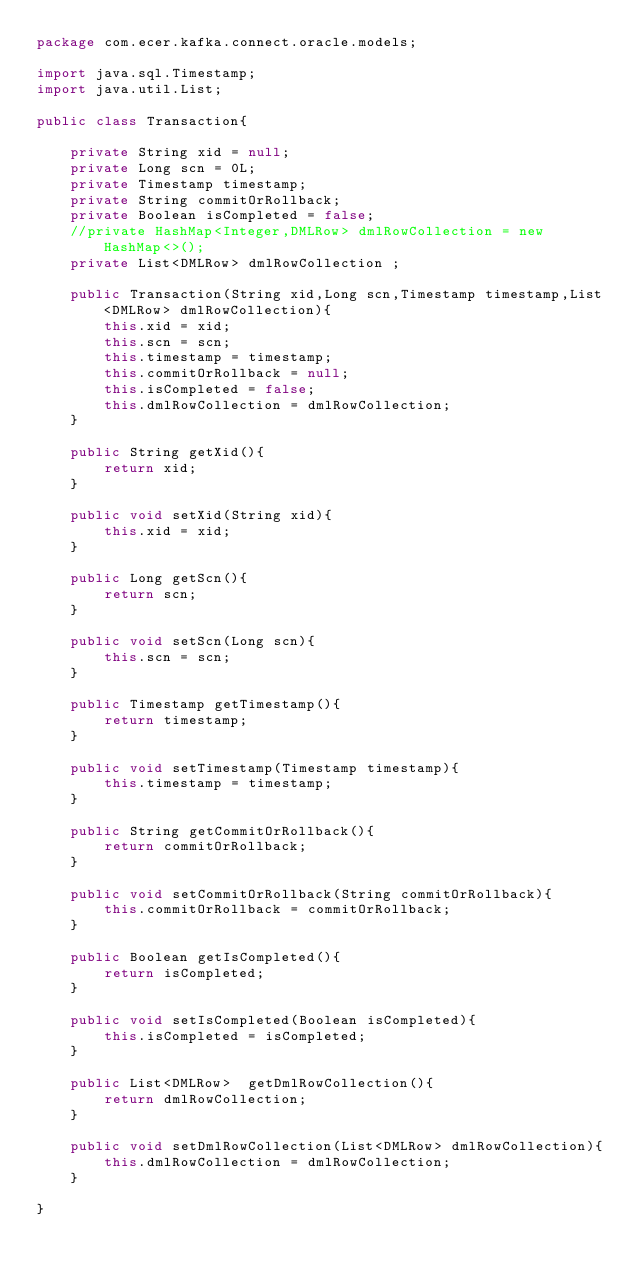Convert code to text. <code><loc_0><loc_0><loc_500><loc_500><_Java_>package com.ecer.kafka.connect.oracle.models;

import java.sql.Timestamp;
import java.util.List;

public class Transaction{

    private String xid = null;
    private Long scn = 0L;
    private Timestamp timestamp;
    private String commitOrRollback;
    private Boolean isCompleted = false;    
    //private HashMap<Integer,DMLRow> dmlRowCollection = new HashMap<>();    
    private List<DMLRow> dmlRowCollection ;

    public Transaction(String xid,Long scn,Timestamp timestamp,List<DMLRow> dmlRowCollection){
        this.xid = xid;
        this.scn = scn;
        this.timestamp = timestamp;
        this.commitOrRollback = null;
        this.isCompleted = false;
        this.dmlRowCollection = dmlRowCollection;
    }

    public String getXid(){
        return xid;
    }

    public void setXid(String xid){
        this.xid = xid;
    }

    public Long getScn(){
        return scn;
    }

    public void setScn(Long scn){
        this.scn = scn;
    }

    public Timestamp getTimestamp(){
        return timestamp;
    }

    public void setTimestamp(Timestamp timestamp){
        this.timestamp = timestamp;
    }    

    public String getCommitOrRollback(){
        return commitOrRollback;
    }

    public void setCommitOrRollback(String commitOrRollback){
        this.commitOrRollback = commitOrRollback;
    }    

    public Boolean getIsCompleted(){
        return isCompleted;
    }

    public void setIsCompleted(Boolean isCompleted){
        this.isCompleted = isCompleted;
    }

    public List<DMLRow>  getDmlRowCollection(){
        return dmlRowCollection;
    }
 
    public void setDmlRowCollection(List<DMLRow> dmlRowCollection){
        this.dmlRowCollection = dmlRowCollection;
    }

}</code> 